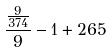<formula> <loc_0><loc_0><loc_500><loc_500>\frac { \frac { 9 } { 3 7 4 } } { 9 } - 1 + 2 6 5</formula> 